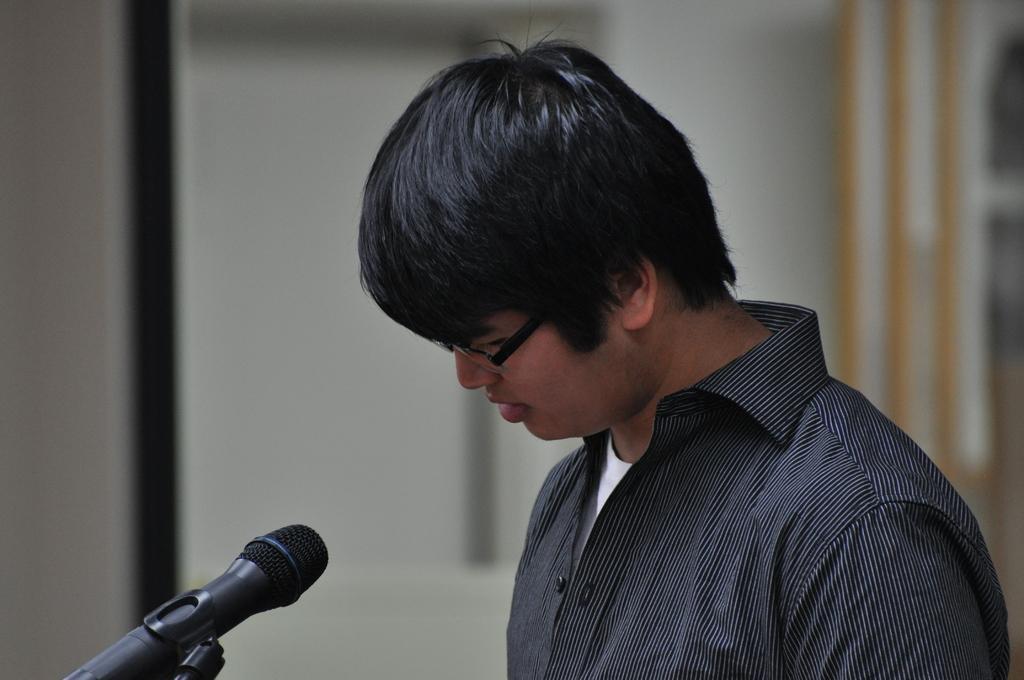Describe this image in one or two sentences. This image consists of a man wearing a black shirt. In front of him, there is a mic along with stand. In the background, it looks like a wall and the background is blurred. 